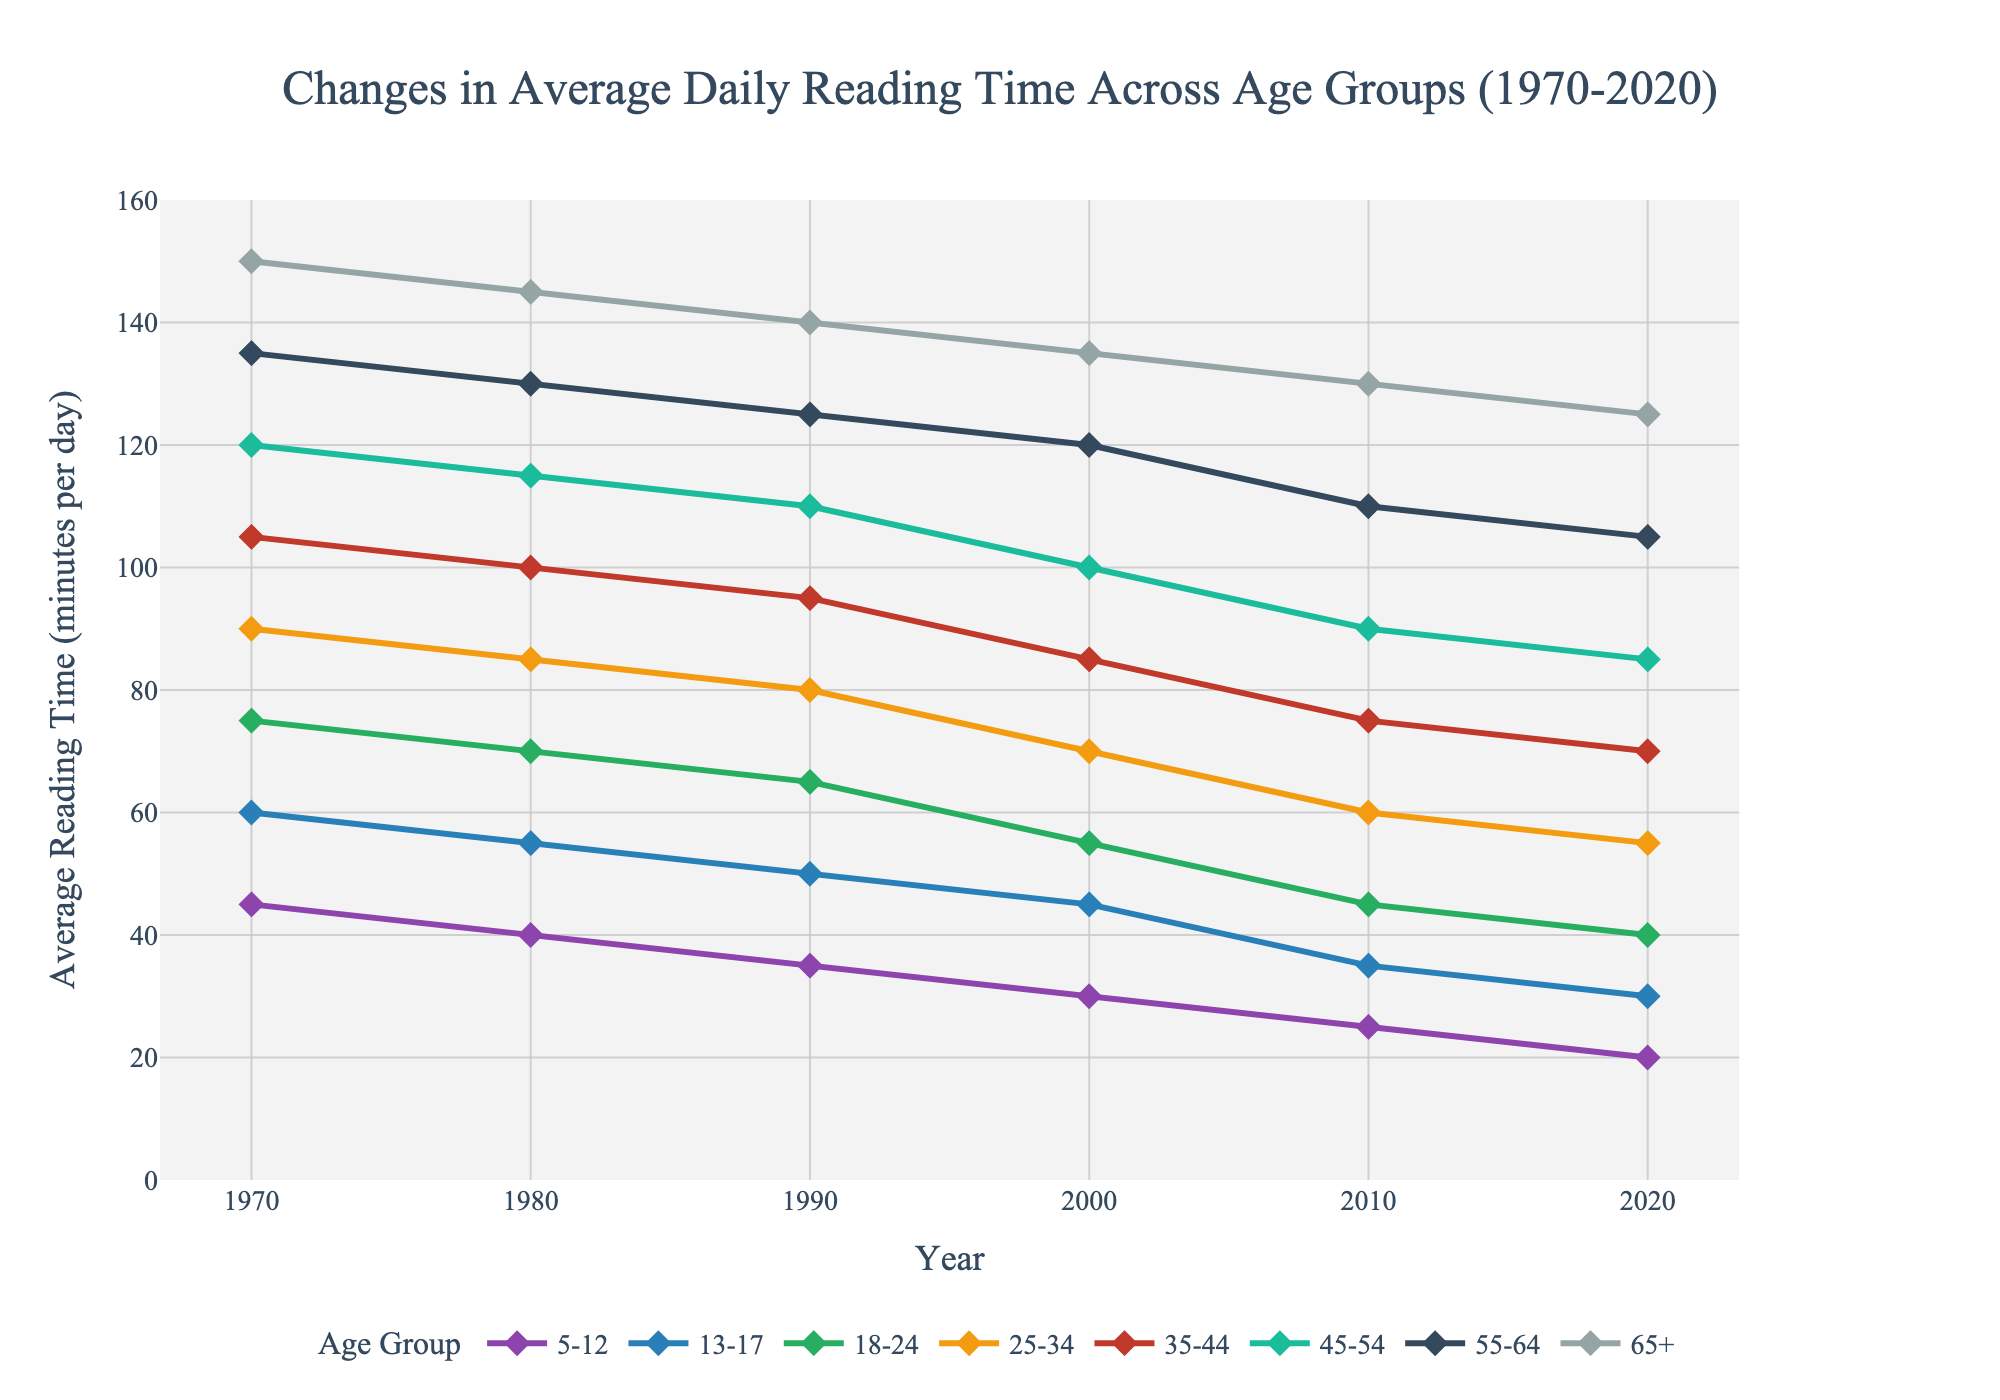What is the trend in average reading time for the 5-12 age group from 1970 to 2020? The trend for the 5-12 age group shows a consistent decline from 45 minutes per day in 1970 to 20 minutes per day in 2020.
Answer: Declining Which age group had the highest average reading time in 1970? In 1970, the 65+ age group had the highest average reading time, which was 150 minutes per day.
Answer: 65+ By how many minutes did the average reading time for the 25-34 age group decrease from 1970 to 2020? The average reading time for the 25-34 age group decreased from 90 minutes per day in 1970 to 55 minutes per day in 2020. The decrease is 90 - 55 = 35.
Answer: 35 minutes What is the average change in reading time per decade for the 45-54 age group from 1970 to 2020? The average reading times for the 45-54 age group in each decade are: 120, 115, 110, 100, 90, 85. The changes per decade are: -5, -5, -10, -10, -5. The average change is (-5 + -5 + -10 + -10 + -5) / 5 = -7.
Answer: -7 minutes per decade Comparing 1980 and 2020, which age group experienced the greatest decrease in average reading time? By comparing the data for 1980 and 2020 for each age group, the decreases are: 5-12: 40 to 20 (-20), 13-17: 55 to 30 (-25), 18-24: 70 to 40 (-30), 25-34: 85 to 55 (-30), 35-44: 100 to 70 (-30), 45-54: 115 to 85 (-30), 55-64: 130 to 105 (-25), 65+: 145 to 125 (-20). The greatest decrease is shared by the 18-24, 25-34, 35-44, and 45-54 age groups, each with a decrease of 30 minutes.
Answer: 18-24, 25-34, 35-44, 45-54 Which age group shows the most consistent reading time across the decades? The age group 65+ shows the most consistent reading time, with relatively small decreases (150, 145, 140, 135, 130, 125), compared to other age groups.
Answer: 65+ How has the gap in reading time between the 5-12 and 65+ age groups changed from 1970 to 2020? In 1970, the gap between the 5-12 and 65+ age groups was 150 - 45 = 105 minutes. In 2020, the gap is 125 - 20 = 105 minutes. The gap has remained the same at 105 minutes.
Answer: Unchanged Which age group showed the fastest decline in average reading time from 2000 to 2010? The changes from 2000 to 2010 for each age group are: 5-12: 30 to 25 (-5), 13-17: 45 to 35 (-10), 18-24: 55 to 45 (-10), 25-34: 70 to 60 (-10), 35-44: 85 to 75 (-10), 45-54: 100 to 90 (-10), 55-64: 120 to 110 (-10), 65+: 135 to 130 (-5). The 13-17, 18-24, 25-34, 35-44, 45-54, and 55-64 age groups all showed declines of 10 minutes, the fastest decline.
Answer: 13-17, 18-24, 25-34, 35-44, 45-54, 55-64 Between 1970 and 2020, which age group had the smallest total decrease in average reading time? The total decreases from 1970 to 2020 for each age group are: 5-12: 45 to 20 (-25), 13-17: 60 to 30 (-30), 18-24: 75 to 40 (-35), 25-34: 90 to 55 (-35), 35-44: 105 to 70 (-35), 45-54: 120 to 85 (-35), 55-64: 135 to 105 (-30), 65+: 150 to 125 (-25). The 5-12 and 65+ age groups had the smallest total decrease, both decreasing by 25 minutes.
Answer: 5-12, 65+ 